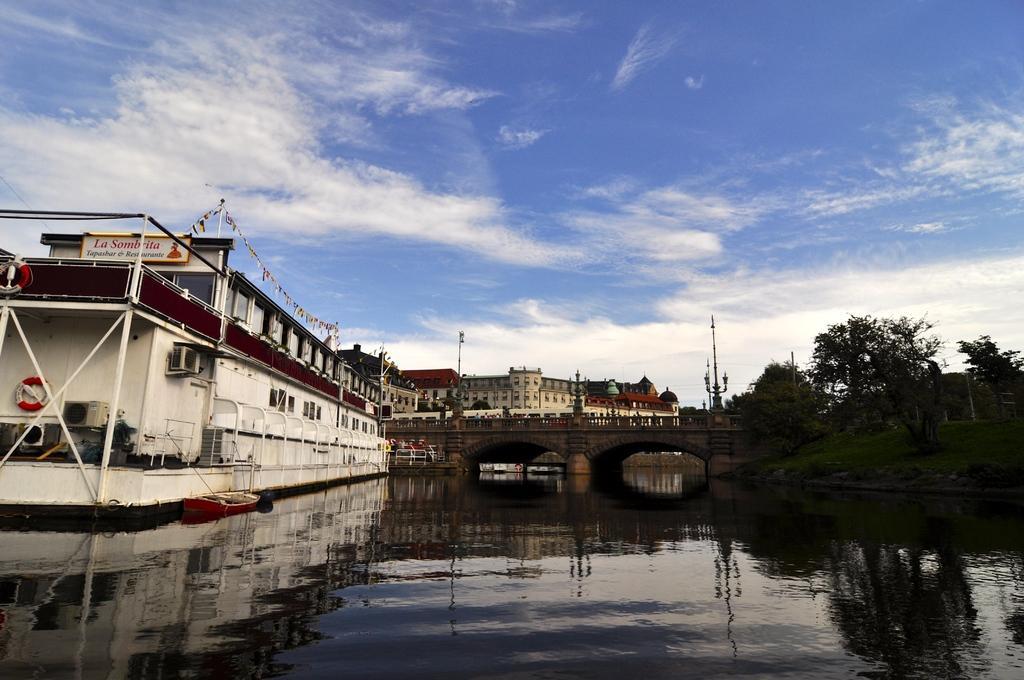Describe this image in one or two sentences. In front of the image there is a river, on top of the river there is a bridge, besides the river there are ships and trees, in the background of the image there are buildings, at the top of the image there are clouds in the sky. 